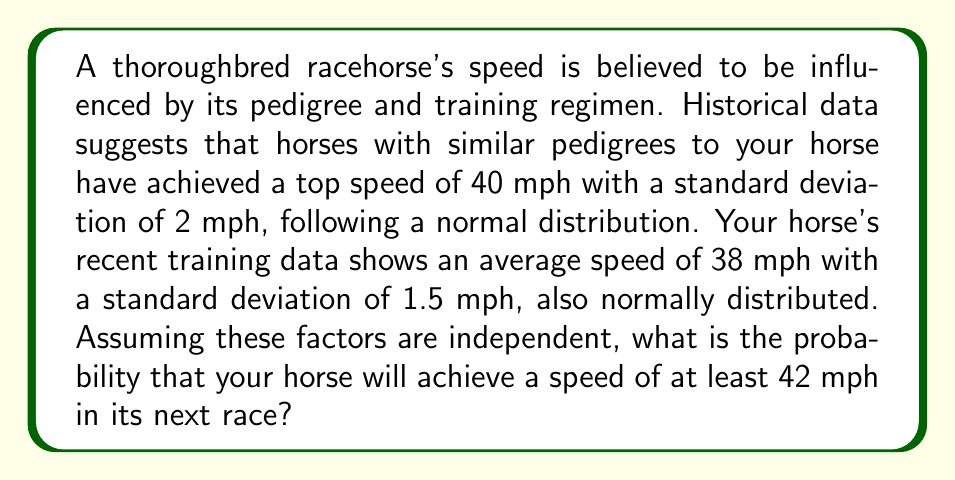Teach me how to tackle this problem. To solve this problem, we need to combine the information from both the pedigree data and the training data to estimate the likelihood of the horse achieving a speed of at least 42 mph. We'll use the concept of convolution of normal distributions.

1. Given information:
   - Pedigree data: $\mu_1 = 40$ mph, $\sigma_1 = 2$ mph
   - Training data: $\mu_2 = 38$ mph, $\sigma_2 = 1.5$ mph

2. When we combine two independent normal distributions, the resulting distribution is also normal with:
   $\mu_{combined} = \mu_1 + \mu_2$
   $\sigma_{combined}^2 = \sigma_1^2 + \sigma_2^2$

3. Calculate the combined mean:
   $\mu_{combined} = 40 + 38 = 78$ mph

4. Calculate the combined standard deviation:
   $\sigma_{combined}^2 = 2^2 + 1.5^2 = 4 + 2.25 = 6.25$
   $\sigma_{combined} = \sqrt{6.25} = 2.5$ mph

5. Now we have a normal distribution with $\mu = 78$ mph and $\sigma = 2.5$ mph

6. To find the probability of achieving at least 42 mph, we need to calculate the z-score:
   $z = \frac{x - \mu}{\sigma} = \frac{42 - 78}{2.5} = -14.4$

7. The probability of achieving at least 42 mph is equivalent to the area under the standard normal curve to the right of z = -14.4.

8. Using a standard normal table or calculator, we find:
   $P(Z > -14.4) \approx 1$

This means that the probability is extremely close to 1, or 100%.
Answer: The probability that the horse will achieve a speed of at least 42 mph in its next race is approximately 1 or 100%. 